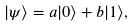<formula> <loc_0><loc_0><loc_500><loc_500>\left | \psi \right \rangle = a | 0 \rangle + b | 1 \rangle ,</formula> 